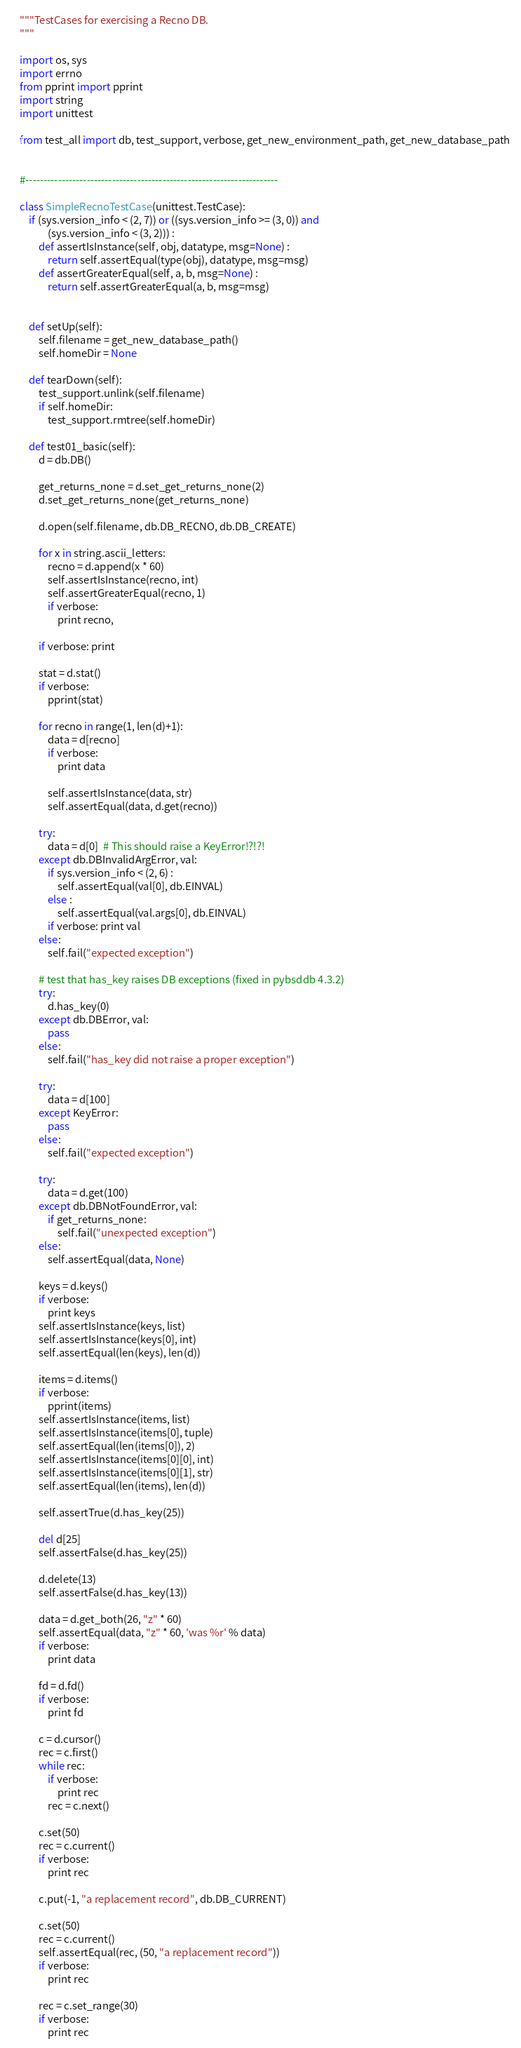Convert code to text. <code><loc_0><loc_0><loc_500><loc_500><_Python_>"""TestCases for exercising a Recno DB.
"""

import os, sys
import errno
from pprint import pprint
import string
import unittest

from test_all import db, test_support, verbose, get_new_environment_path, get_new_database_path


#----------------------------------------------------------------------

class SimpleRecnoTestCase(unittest.TestCase):
    if (sys.version_info < (2, 7)) or ((sys.version_info >= (3, 0)) and
            (sys.version_info < (3, 2))) :
        def assertIsInstance(self, obj, datatype, msg=None) :
            return self.assertEqual(type(obj), datatype, msg=msg)
        def assertGreaterEqual(self, a, b, msg=None) :
            return self.assertGreaterEqual(a, b, msg=msg)


    def setUp(self):
        self.filename = get_new_database_path()
        self.homeDir = None

    def tearDown(self):
        test_support.unlink(self.filename)
        if self.homeDir:
            test_support.rmtree(self.homeDir)

    def test01_basic(self):
        d = db.DB()

        get_returns_none = d.set_get_returns_none(2)
        d.set_get_returns_none(get_returns_none)

        d.open(self.filename, db.DB_RECNO, db.DB_CREATE)

        for x in string.ascii_letters:
            recno = d.append(x * 60)
            self.assertIsInstance(recno, int)
            self.assertGreaterEqual(recno, 1)
            if verbose:
                print recno,

        if verbose: print

        stat = d.stat()
        if verbose:
            pprint(stat)

        for recno in range(1, len(d)+1):
            data = d[recno]
            if verbose:
                print data

            self.assertIsInstance(data, str)
            self.assertEqual(data, d.get(recno))

        try:
            data = d[0]  # This should raise a KeyError!?!?!
        except db.DBInvalidArgError, val:
            if sys.version_info < (2, 6) :
                self.assertEqual(val[0], db.EINVAL)
            else :
                self.assertEqual(val.args[0], db.EINVAL)
            if verbose: print val
        else:
            self.fail("expected exception")

        # test that has_key raises DB exceptions (fixed in pybsddb 4.3.2)
        try:
            d.has_key(0)
        except db.DBError, val:
            pass
        else:
            self.fail("has_key did not raise a proper exception")

        try:
            data = d[100]
        except KeyError:
            pass
        else:
            self.fail("expected exception")

        try:
            data = d.get(100)
        except db.DBNotFoundError, val:
            if get_returns_none:
                self.fail("unexpected exception")
        else:
            self.assertEqual(data, None)

        keys = d.keys()
        if verbose:
            print keys
        self.assertIsInstance(keys, list)
        self.assertIsInstance(keys[0], int)
        self.assertEqual(len(keys), len(d))

        items = d.items()
        if verbose:
            pprint(items)
        self.assertIsInstance(items, list)
        self.assertIsInstance(items[0], tuple)
        self.assertEqual(len(items[0]), 2)
        self.assertIsInstance(items[0][0], int)
        self.assertIsInstance(items[0][1], str)
        self.assertEqual(len(items), len(d))

        self.assertTrue(d.has_key(25))

        del d[25]
        self.assertFalse(d.has_key(25))

        d.delete(13)
        self.assertFalse(d.has_key(13))

        data = d.get_both(26, "z" * 60)
        self.assertEqual(data, "z" * 60, 'was %r' % data)
        if verbose:
            print data

        fd = d.fd()
        if verbose:
            print fd

        c = d.cursor()
        rec = c.first()
        while rec:
            if verbose:
                print rec
            rec = c.next()

        c.set(50)
        rec = c.current()
        if verbose:
            print rec

        c.put(-1, "a replacement record", db.DB_CURRENT)

        c.set(50)
        rec = c.current()
        self.assertEqual(rec, (50, "a replacement record"))
        if verbose:
            print rec

        rec = c.set_range(30)
        if verbose:
            print rec
</code> 